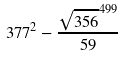<formula> <loc_0><loc_0><loc_500><loc_500>3 7 7 ^ { 2 } - \frac { \sqrt { 3 5 6 } ^ { 4 9 9 } } { 5 9 }</formula> 